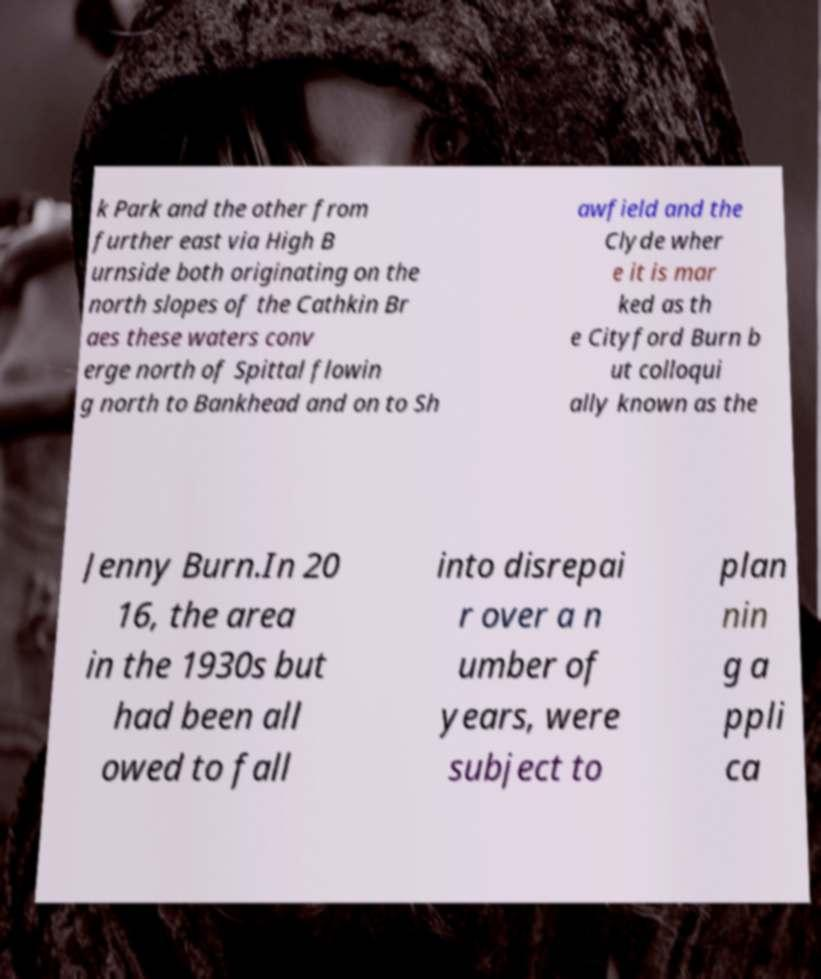Could you extract and type out the text from this image? k Park and the other from further east via High B urnside both originating on the north slopes of the Cathkin Br aes these waters conv erge north of Spittal flowin g north to Bankhead and on to Sh awfield and the Clyde wher e it is mar ked as th e Cityford Burn b ut colloqui ally known as the Jenny Burn.In 20 16, the area in the 1930s but had been all owed to fall into disrepai r over a n umber of years, were subject to plan nin g a ppli ca 